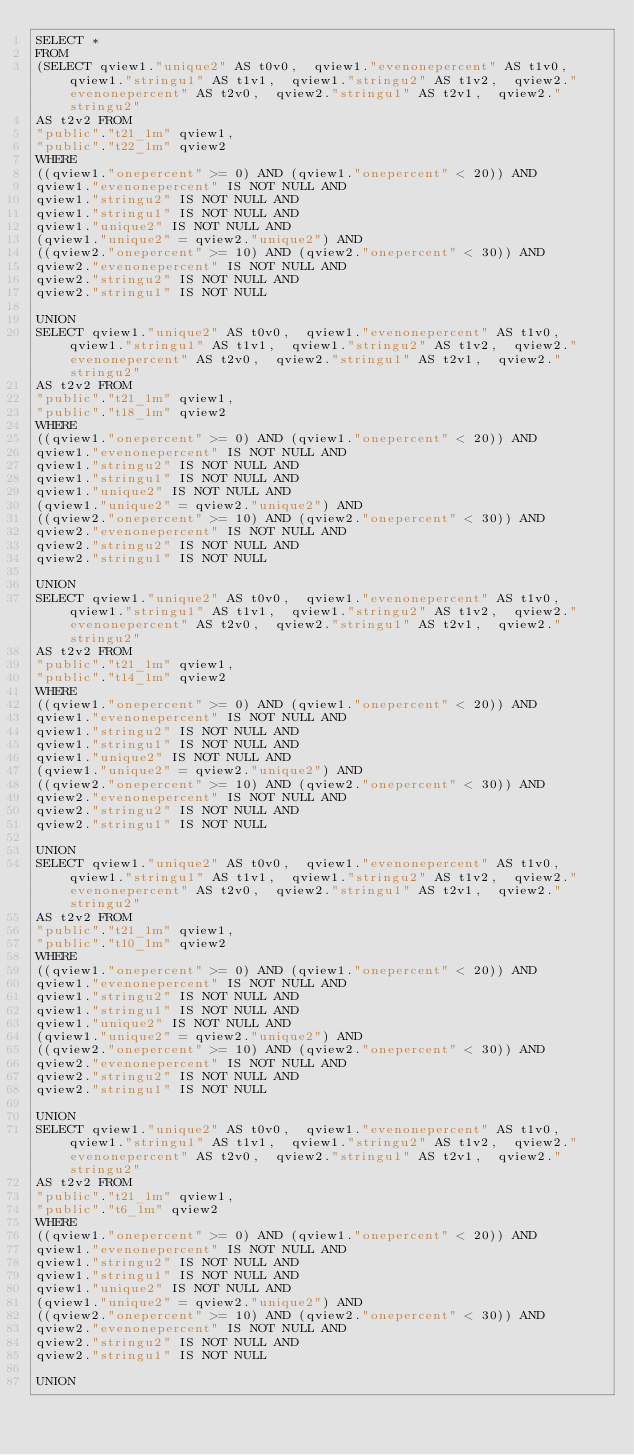<code> <loc_0><loc_0><loc_500><loc_500><_SQL_>SELECT *
FROM
(SELECT qview1."unique2" AS t0v0,  qview1."evenonepercent" AS t1v0,  qview1."stringu1" AS t1v1,  qview1."stringu2" AS t1v2,  qview2."evenonepercent" AS t2v0,  qview2."stringu1" AS t2v1,  qview2."stringu2"
AS t2v2 FROM
"public"."t21_1m" qview1,
"public"."t22_1m" qview2
WHERE
((qview1."onepercent" >= 0) AND (qview1."onepercent" < 20)) AND
qview1."evenonepercent" IS NOT NULL AND
qview1."stringu2" IS NOT NULL AND
qview1."stringu1" IS NOT NULL AND
qview1."unique2" IS NOT NULL AND
(qview1."unique2" = qview2."unique2") AND
((qview2."onepercent" >= 10) AND (qview2."onepercent" < 30)) AND
qview2."evenonepercent" IS NOT NULL AND
qview2."stringu2" IS NOT NULL AND
qview2."stringu1" IS NOT NULL

UNION
SELECT qview1."unique2" AS t0v0,  qview1."evenonepercent" AS t1v0,  qview1."stringu1" AS t1v1,  qview1."stringu2" AS t1v2,  qview2."evenonepercent" AS t2v0,  qview2."stringu1" AS t2v1,  qview2."stringu2"
AS t2v2 FROM
"public"."t21_1m" qview1,
"public"."t18_1m" qview2
WHERE
((qview1."onepercent" >= 0) AND (qview1."onepercent" < 20)) AND
qview1."evenonepercent" IS NOT NULL AND
qview1."stringu2" IS NOT NULL AND
qview1."stringu1" IS NOT NULL AND
qview1."unique2" IS NOT NULL AND
(qview1."unique2" = qview2."unique2") AND
((qview2."onepercent" >= 10) AND (qview2."onepercent" < 30)) AND
qview2."evenonepercent" IS NOT NULL AND
qview2."stringu2" IS NOT NULL AND
qview2."stringu1" IS NOT NULL

UNION
SELECT qview1."unique2" AS t0v0,  qview1."evenonepercent" AS t1v0,  qview1."stringu1" AS t1v1,  qview1."stringu2" AS t1v2,  qview2."evenonepercent" AS t2v0,  qview2."stringu1" AS t2v1,  qview2."stringu2"
AS t2v2 FROM
"public"."t21_1m" qview1,
"public"."t14_1m" qview2
WHERE
((qview1."onepercent" >= 0) AND (qview1."onepercent" < 20)) AND
qview1."evenonepercent" IS NOT NULL AND
qview1."stringu2" IS NOT NULL AND
qview1."stringu1" IS NOT NULL AND
qview1."unique2" IS NOT NULL AND
(qview1."unique2" = qview2."unique2") AND
((qview2."onepercent" >= 10) AND (qview2."onepercent" < 30)) AND
qview2."evenonepercent" IS NOT NULL AND
qview2."stringu2" IS NOT NULL AND
qview2."stringu1" IS NOT NULL

UNION
SELECT qview1."unique2" AS t0v0,  qview1."evenonepercent" AS t1v0,  qview1."stringu1" AS t1v1,  qview1."stringu2" AS t1v2,  qview2."evenonepercent" AS t2v0,  qview2."stringu1" AS t2v1,  qview2."stringu2"
AS t2v2 FROM
"public"."t21_1m" qview1,
"public"."t10_1m" qview2
WHERE
((qview1."onepercent" >= 0) AND (qview1."onepercent" < 20)) AND
qview1."evenonepercent" IS NOT NULL AND
qview1."stringu2" IS NOT NULL AND
qview1."stringu1" IS NOT NULL AND
qview1."unique2" IS NOT NULL AND
(qview1."unique2" = qview2."unique2") AND
((qview2."onepercent" >= 10) AND (qview2."onepercent" < 30)) AND
qview2."evenonepercent" IS NOT NULL AND
qview2."stringu2" IS NOT NULL AND
qview2."stringu1" IS NOT NULL

UNION
SELECT qview1."unique2" AS t0v0,  qview1."evenonepercent" AS t1v0,  qview1."stringu1" AS t1v1,  qview1."stringu2" AS t1v2,  qview2."evenonepercent" AS t2v0,  qview2."stringu1" AS t2v1,  qview2."stringu2"
AS t2v2 FROM
"public"."t21_1m" qview1,
"public"."t6_1m" qview2
WHERE
((qview1."onepercent" >= 0) AND (qview1."onepercent" < 20)) AND
qview1."evenonepercent" IS NOT NULL AND
qview1."stringu2" IS NOT NULL AND
qview1."stringu1" IS NOT NULL AND
qview1."unique2" IS NOT NULL AND
(qview1."unique2" = qview2."unique2") AND
((qview2."onepercent" >= 10) AND (qview2."onepercent" < 30)) AND
qview2."evenonepercent" IS NOT NULL AND
qview2."stringu2" IS NOT NULL AND
qview2."stringu1" IS NOT NULL

UNION</code> 